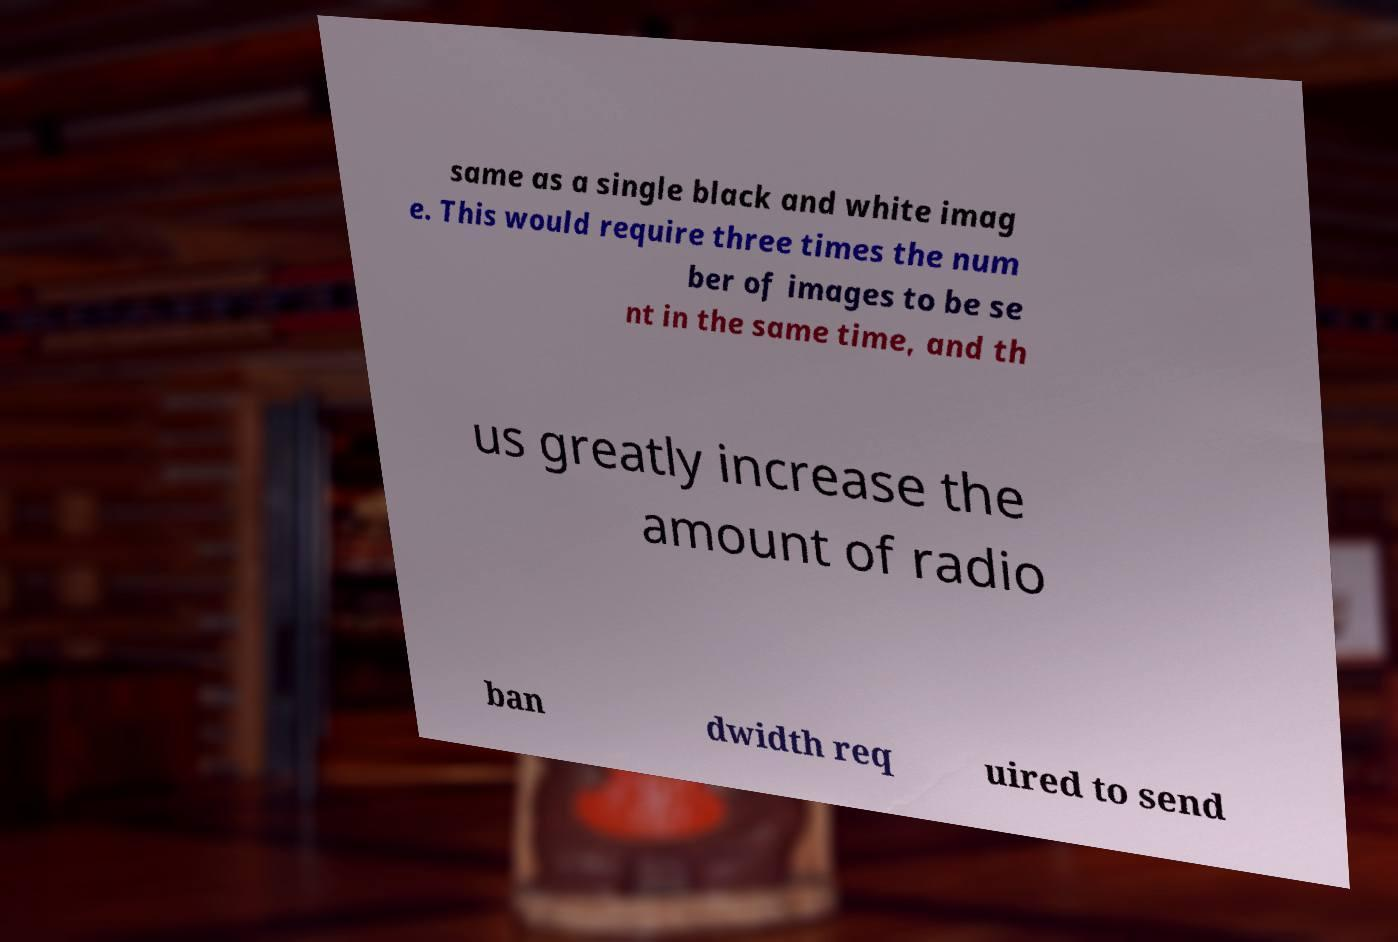Please read and relay the text visible in this image. What does it say? same as a single black and white imag e. This would require three times the num ber of images to be se nt in the same time, and th us greatly increase the amount of radio ban dwidth req uired to send 